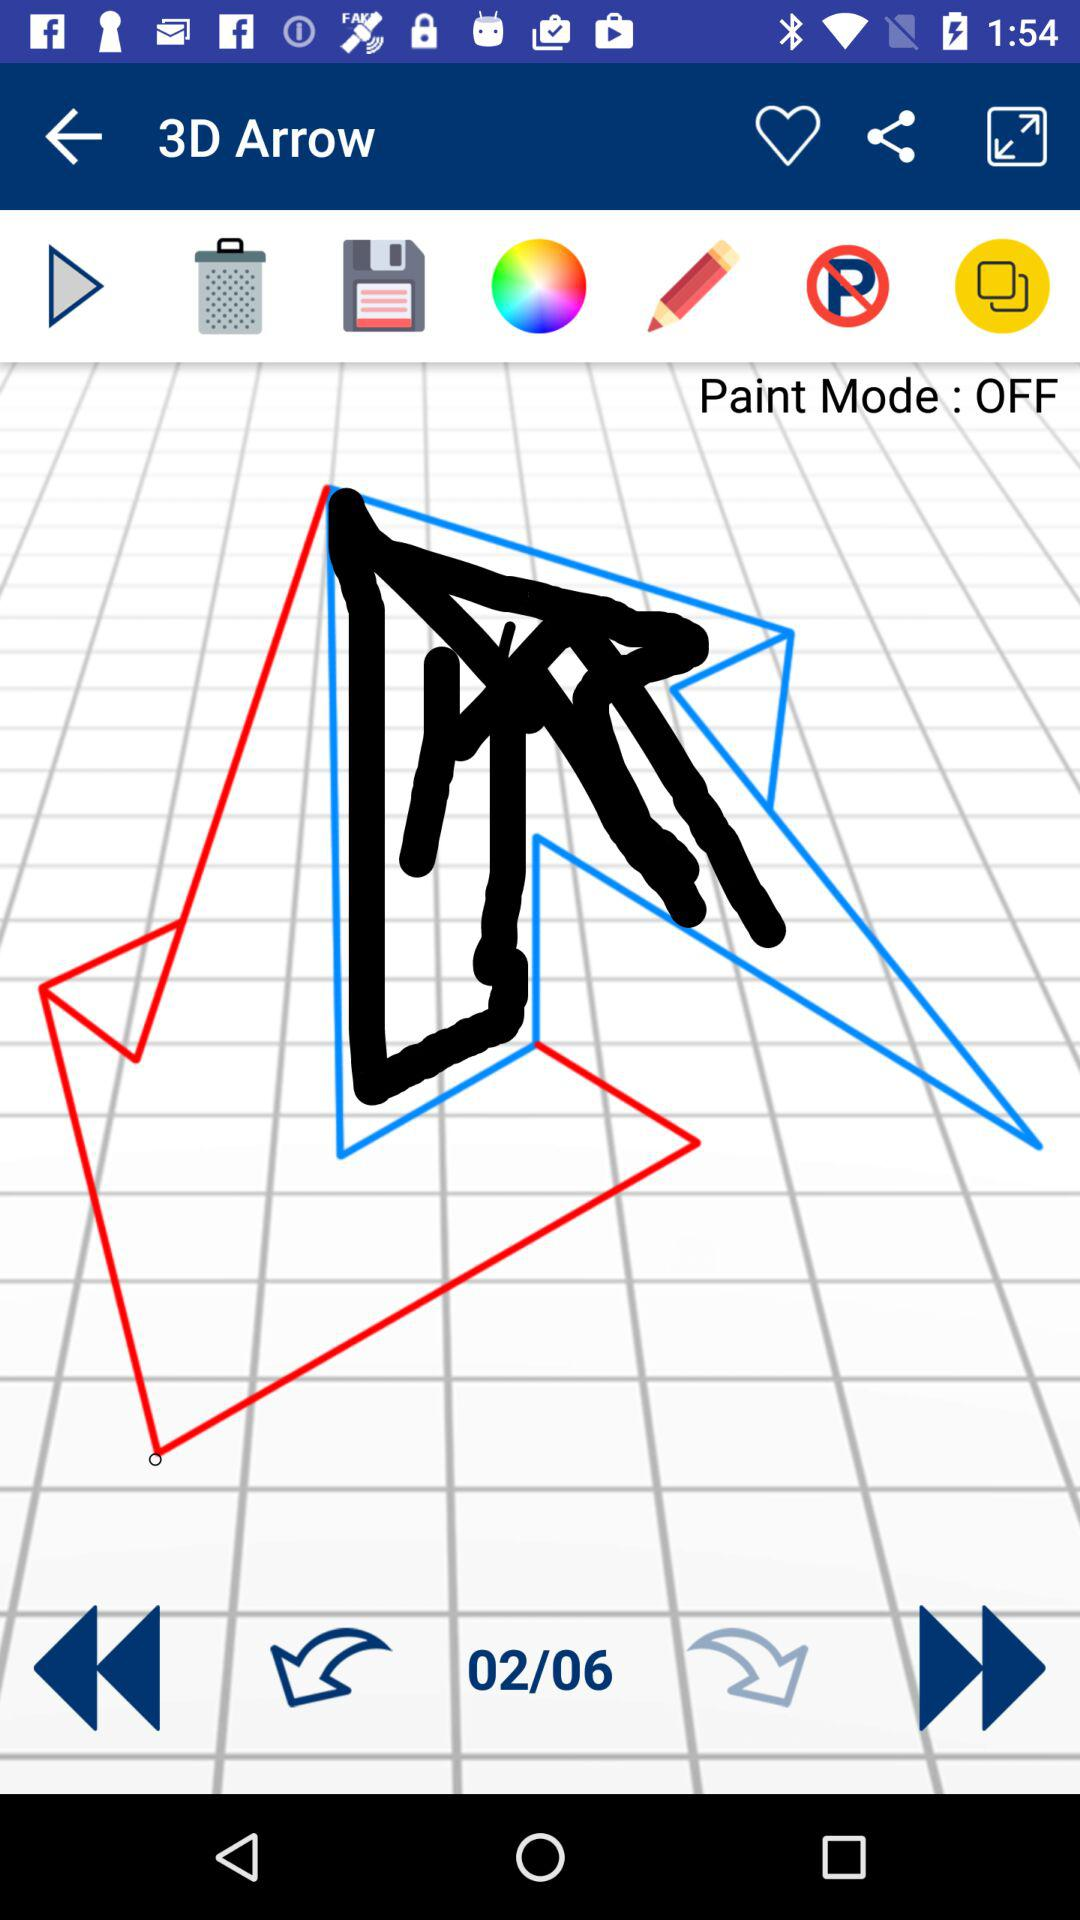What's the status of "Paint Mode"? The status of "Paint Mode" is "off". 